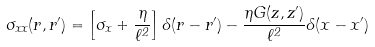<formula> <loc_0><loc_0><loc_500><loc_500>\sigma _ { x x } ( { r , r ^ { \prime } } ) = \left [ \sigma _ { x } + \frac { \eta } { \ell ^ { 2 } } \right ] \delta ( { r - r ^ { \prime } } ) - \frac { \eta G ( z , z ^ { \prime } ) } { \ell ^ { 2 } } \delta ( x - x ^ { \prime } )</formula> 